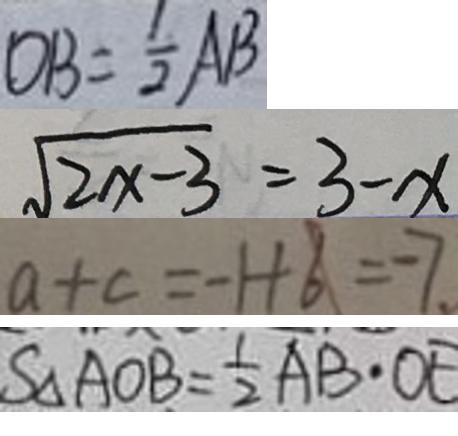<formula> <loc_0><loc_0><loc_500><loc_500>O B = \frac { 1 } { 2 } A B 
 \sqrt { 2 x - 3 } = 3 - x 
 a + c = - 1 + 6 = - 7 . 
 S _ { \Delta A O B } = \frac { 1 } { 2 } A B \cdot O E</formula> 